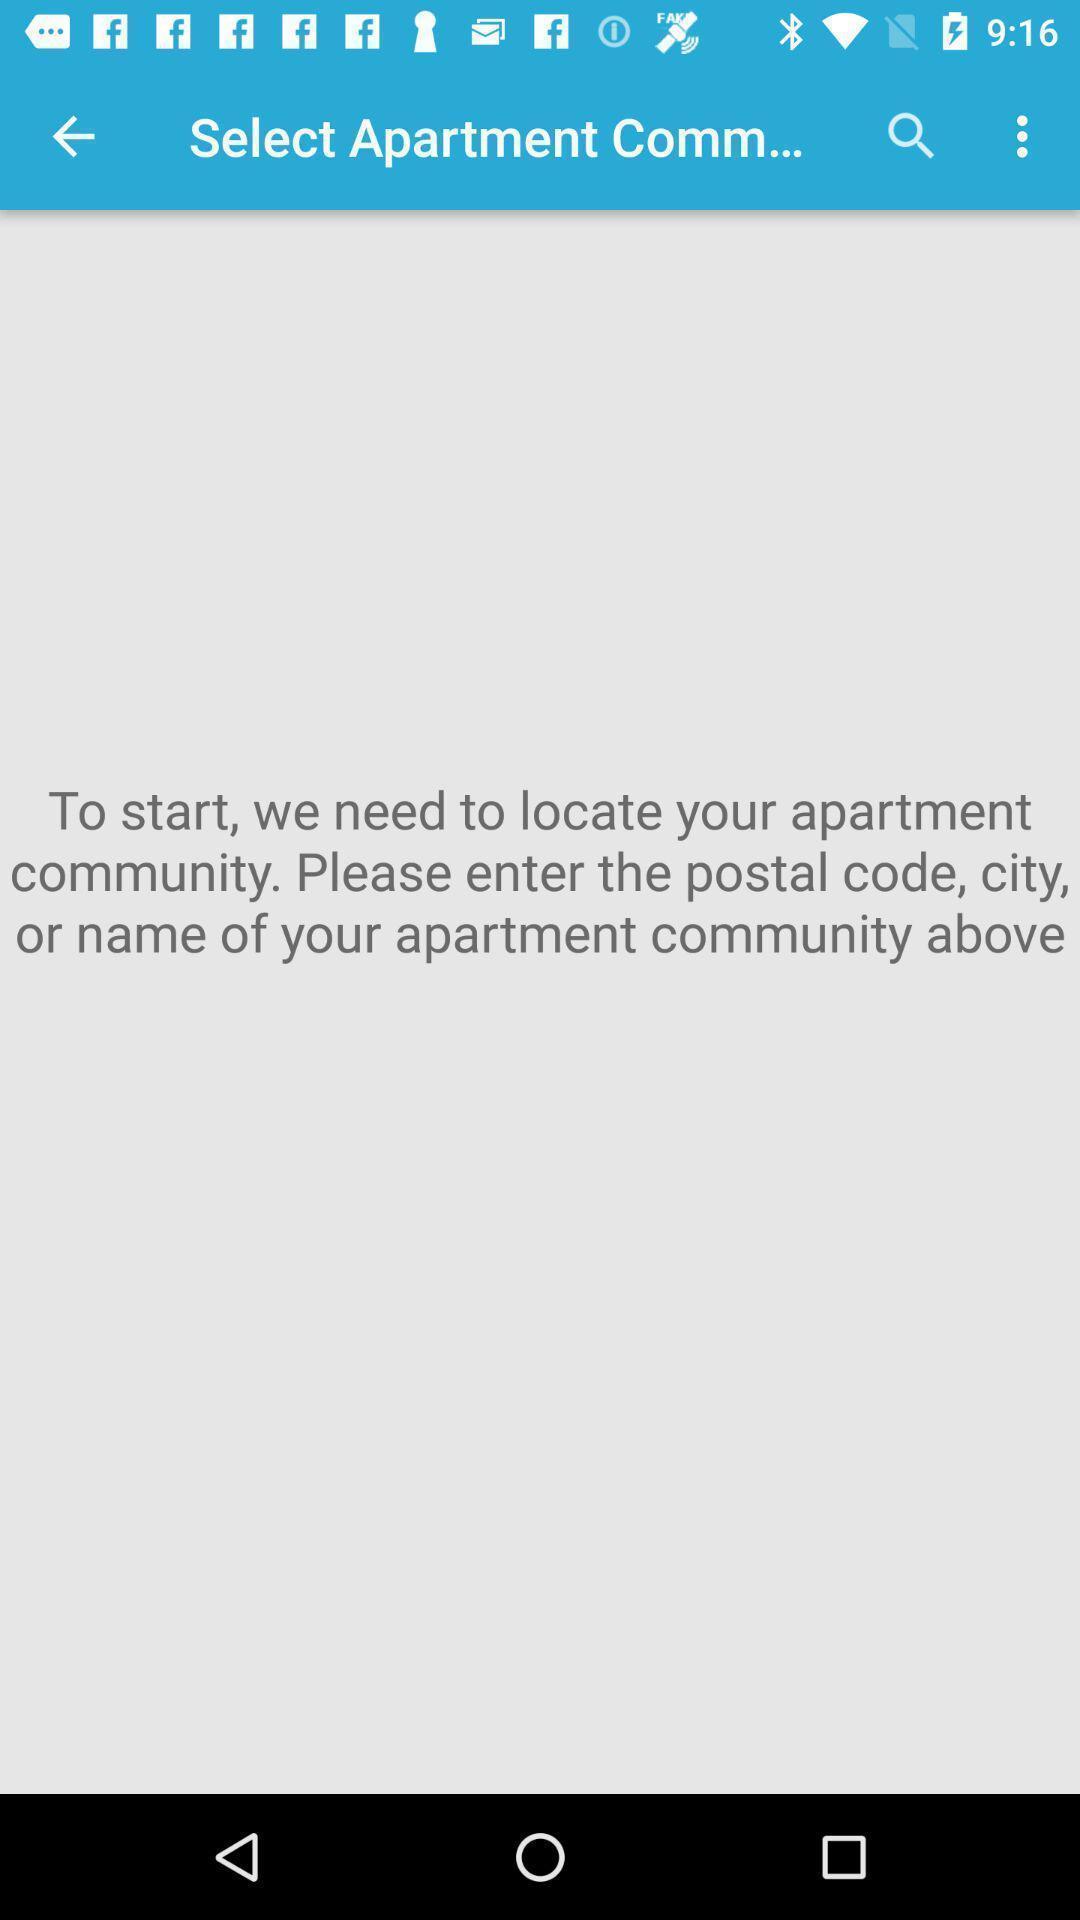Provide a textual representation of this image. Page showing select apartment community. 